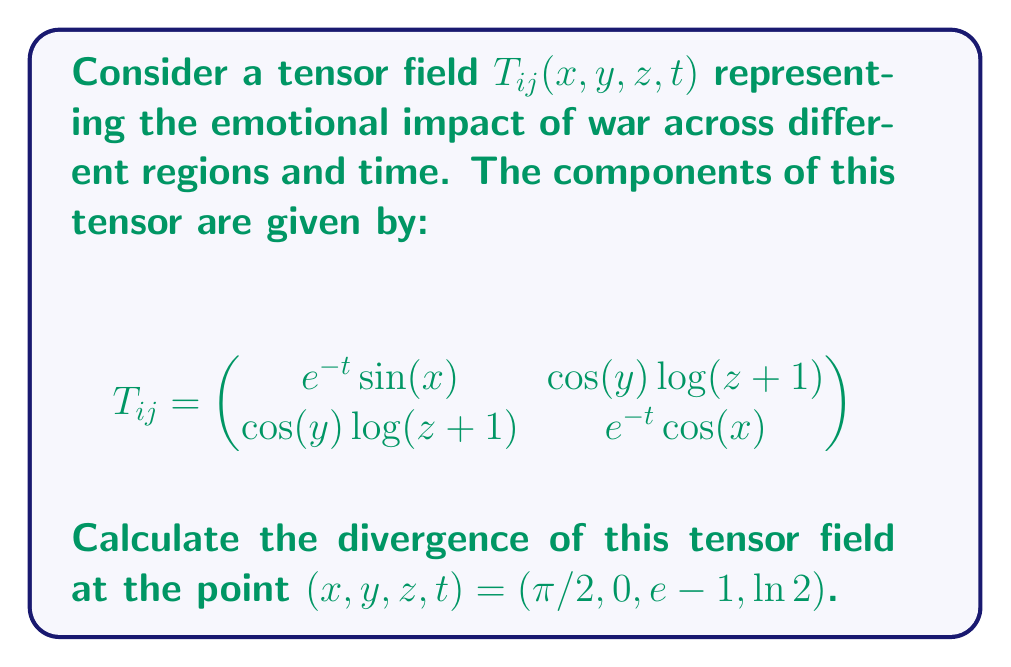Give your solution to this math problem. To calculate the divergence of the tensor field, we need to follow these steps:

1) The divergence of a 2nd order tensor field in 3D space is given by:

   $$\text{div}(T) = \frac{\partial T_{11}}{\partial x} + \frac{\partial T_{12}}{\partial y} + \frac{\partial T_{13}}{\partial z} + \frac{\partial T_{21}}{\partial x} + \frac{\partial T_{22}}{\partial y} + \frac{\partial T_{23}}{\partial z} + \frac{\partial T_{31}}{\partial x} + \frac{\partial T_{32}}{\partial y} + \frac{\partial T_{33}}{\partial z}$$

2) In our case, we only have a 2x2 tensor in a 4D space-time, so we need to calculate:

   $$\text{div}(T) = \frac{\partial T_{11}}{\partial x} + \frac{\partial T_{12}}{\partial y} + \frac{\partial T_{21}}{\partial x} + \frac{\partial T_{22}}{\partial y}$$

3) Let's calculate each term:

   $\frac{\partial T_{11}}{\partial x} = \frac{\partial}{\partial x}(e^{-t}\sin(x)) = e^{-t}\cos(x)$

   $\frac{\partial T_{12}}{\partial y} = \frac{\partial}{\partial y}(\cos(y)\log(z+1)) = -\sin(y)\log(z+1)$

   $\frac{\partial T_{21}}{\partial x} = \frac{\partial}{\partial x}(\cos(y)\log(z+1)) = 0$

   $\frac{\partial T_{22}}{\partial y} = \frac{\partial}{\partial y}(e^{-t}\cos(x)) = 0$

4) Now, we sum these terms and evaluate at the point $(\pi/2, 0, e-1, \ln 2)$:

   $\text{div}(T) = e^{-t}\cos(x) - \sin(y)\log(z+1) + 0 + 0$

   $= e^{-\ln 2}\cos(\pi/2) - \sin(0)\log(e) + 0 + 0$

   $= \frac{1}{2} \cdot 0 - 0 \cdot 1 + 0 + 0 = 0$

Therefore, the divergence of the tensor field at the given point is 0.
Answer: 0 